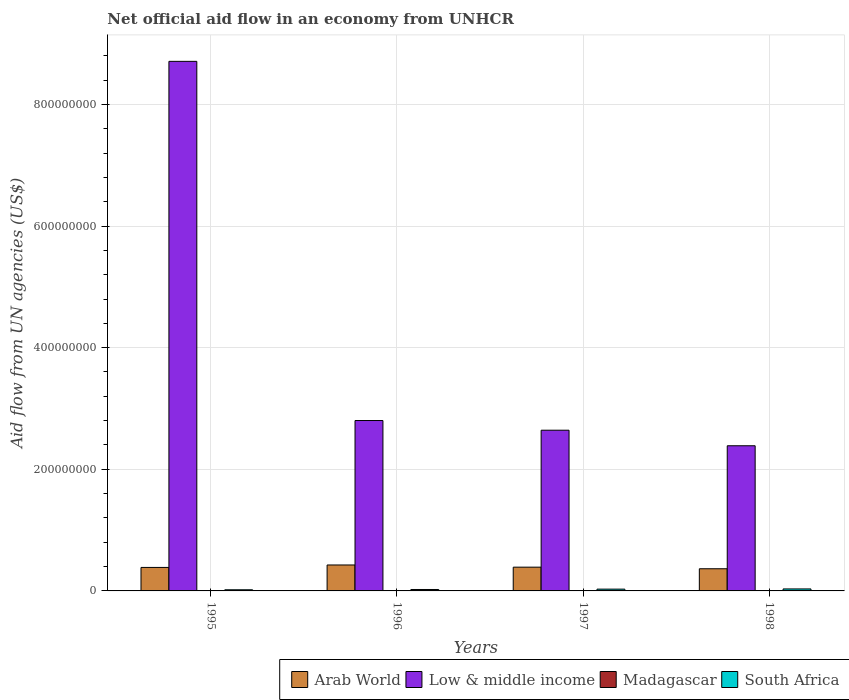Are the number of bars on each tick of the X-axis equal?
Your answer should be compact. Yes. How many bars are there on the 3rd tick from the right?
Make the answer very short. 4. In how many cases, is the number of bars for a given year not equal to the number of legend labels?
Your answer should be very brief. 0. What is the net official aid flow in Arab World in 1997?
Keep it short and to the point. 3.91e+07. Across all years, what is the maximum net official aid flow in Arab World?
Your answer should be compact. 4.27e+07. Across all years, what is the minimum net official aid flow in South Africa?
Make the answer very short. 1.88e+06. In which year was the net official aid flow in South Africa maximum?
Make the answer very short. 1998. In which year was the net official aid flow in South Africa minimum?
Give a very brief answer. 1995. What is the total net official aid flow in Arab World in the graph?
Give a very brief answer. 1.57e+08. What is the difference between the net official aid flow in Arab World in 1995 and that in 1996?
Make the answer very short. -4.03e+06. What is the difference between the net official aid flow in Low & middle income in 1997 and the net official aid flow in South Africa in 1996?
Make the answer very short. 2.62e+08. What is the average net official aid flow in Low & middle income per year?
Your answer should be compact. 4.14e+08. In the year 1996, what is the difference between the net official aid flow in Madagascar and net official aid flow in Arab World?
Your answer should be compact. -4.26e+07. What is the ratio of the net official aid flow in Arab World in 1996 to that in 1997?
Your response must be concise. 1.09. Is the difference between the net official aid flow in Madagascar in 1996 and 1997 greater than the difference between the net official aid flow in Arab World in 1996 and 1997?
Your answer should be compact. No. What is the difference between the highest and the second highest net official aid flow in Low & middle income?
Your answer should be compact. 5.91e+08. Is it the case that in every year, the sum of the net official aid flow in Low & middle income and net official aid flow in Arab World is greater than the sum of net official aid flow in Madagascar and net official aid flow in South Africa?
Make the answer very short. Yes. What does the 1st bar from the left in 1998 represents?
Keep it short and to the point. Arab World. What does the 2nd bar from the right in 1998 represents?
Provide a short and direct response. Madagascar. Is it the case that in every year, the sum of the net official aid flow in Madagascar and net official aid flow in South Africa is greater than the net official aid flow in Arab World?
Provide a short and direct response. No. How many bars are there?
Your response must be concise. 16. Are all the bars in the graph horizontal?
Your response must be concise. No. What is the difference between two consecutive major ticks on the Y-axis?
Your response must be concise. 2.00e+08. Are the values on the major ticks of Y-axis written in scientific E-notation?
Your response must be concise. No. Does the graph contain any zero values?
Ensure brevity in your answer.  No. Where does the legend appear in the graph?
Offer a terse response. Bottom right. How many legend labels are there?
Make the answer very short. 4. What is the title of the graph?
Give a very brief answer. Net official aid flow in an economy from UNHCR. What is the label or title of the X-axis?
Provide a succinct answer. Years. What is the label or title of the Y-axis?
Keep it short and to the point. Aid flow from UN agencies (US$). What is the Aid flow from UN agencies (US$) of Arab World in 1995?
Your answer should be compact. 3.86e+07. What is the Aid flow from UN agencies (US$) of Low & middle income in 1995?
Your answer should be very brief. 8.71e+08. What is the Aid flow from UN agencies (US$) in South Africa in 1995?
Ensure brevity in your answer.  1.88e+06. What is the Aid flow from UN agencies (US$) in Arab World in 1996?
Provide a succinct answer. 4.27e+07. What is the Aid flow from UN agencies (US$) of Low & middle income in 1996?
Ensure brevity in your answer.  2.80e+08. What is the Aid flow from UN agencies (US$) in Madagascar in 1996?
Your answer should be compact. 6.00e+04. What is the Aid flow from UN agencies (US$) in South Africa in 1996?
Ensure brevity in your answer.  2.35e+06. What is the Aid flow from UN agencies (US$) in Arab World in 1997?
Provide a succinct answer. 3.91e+07. What is the Aid flow from UN agencies (US$) in Low & middle income in 1997?
Give a very brief answer. 2.64e+08. What is the Aid flow from UN agencies (US$) of Madagascar in 1997?
Give a very brief answer. 5.00e+04. What is the Aid flow from UN agencies (US$) in South Africa in 1997?
Your response must be concise. 2.94e+06. What is the Aid flow from UN agencies (US$) in Arab World in 1998?
Keep it short and to the point. 3.64e+07. What is the Aid flow from UN agencies (US$) of Low & middle income in 1998?
Make the answer very short. 2.39e+08. What is the Aid flow from UN agencies (US$) of Madagascar in 1998?
Offer a very short reply. 4.00e+04. What is the Aid flow from UN agencies (US$) of South Africa in 1998?
Provide a short and direct response. 3.27e+06. Across all years, what is the maximum Aid flow from UN agencies (US$) of Arab World?
Your response must be concise. 4.27e+07. Across all years, what is the maximum Aid flow from UN agencies (US$) in Low & middle income?
Provide a succinct answer. 8.71e+08. Across all years, what is the maximum Aid flow from UN agencies (US$) of Madagascar?
Provide a succinct answer. 6.00e+04. Across all years, what is the maximum Aid flow from UN agencies (US$) of South Africa?
Provide a short and direct response. 3.27e+06. Across all years, what is the minimum Aid flow from UN agencies (US$) in Arab World?
Provide a succinct answer. 3.64e+07. Across all years, what is the minimum Aid flow from UN agencies (US$) of Low & middle income?
Your answer should be very brief. 2.39e+08. Across all years, what is the minimum Aid flow from UN agencies (US$) of Madagascar?
Your response must be concise. 4.00e+04. Across all years, what is the minimum Aid flow from UN agencies (US$) in South Africa?
Offer a very short reply. 1.88e+06. What is the total Aid flow from UN agencies (US$) in Arab World in the graph?
Your answer should be compact. 1.57e+08. What is the total Aid flow from UN agencies (US$) in Low & middle income in the graph?
Provide a short and direct response. 1.65e+09. What is the total Aid flow from UN agencies (US$) in Madagascar in the graph?
Offer a terse response. 1.90e+05. What is the total Aid flow from UN agencies (US$) in South Africa in the graph?
Make the answer very short. 1.04e+07. What is the difference between the Aid flow from UN agencies (US$) in Arab World in 1995 and that in 1996?
Your response must be concise. -4.03e+06. What is the difference between the Aid flow from UN agencies (US$) in Low & middle income in 1995 and that in 1996?
Ensure brevity in your answer.  5.91e+08. What is the difference between the Aid flow from UN agencies (US$) of Madagascar in 1995 and that in 1996?
Provide a succinct answer. -2.00e+04. What is the difference between the Aid flow from UN agencies (US$) of South Africa in 1995 and that in 1996?
Provide a short and direct response. -4.70e+05. What is the difference between the Aid flow from UN agencies (US$) in Arab World in 1995 and that in 1997?
Your answer should be compact. -4.30e+05. What is the difference between the Aid flow from UN agencies (US$) of Low & middle income in 1995 and that in 1997?
Your answer should be compact. 6.07e+08. What is the difference between the Aid flow from UN agencies (US$) in South Africa in 1995 and that in 1997?
Your answer should be compact. -1.06e+06. What is the difference between the Aid flow from UN agencies (US$) of Arab World in 1995 and that in 1998?
Offer a very short reply. 2.18e+06. What is the difference between the Aid flow from UN agencies (US$) in Low & middle income in 1995 and that in 1998?
Make the answer very short. 6.32e+08. What is the difference between the Aid flow from UN agencies (US$) of Madagascar in 1995 and that in 1998?
Your answer should be very brief. 0. What is the difference between the Aid flow from UN agencies (US$) in South Africa in 1995 and that in 1998?
Give a very brief answer. -1.39e+06. What is the difference between the Aid flow from UN agencies (US$) in Arab World in 1996 and that in 1997?
Ensure brevity in your answer.  3.60e+06. What is the difference between the Aid flow from UN agencies (US$) in Low & middle income in 1996 and that in 1997?
Ensure brevity in your answer.  1.59e+07. What is the difference between the Aid flow from UN agencies (US$) in South Africa in 1996 and that in 1997?
Make the answer very short. -5.90e+05. What is the difference between the Aid flow from UN agencies (US$) of Arab World in 1996 and that in 1998?
Provide a succinct answer. 6.21e+06. What is the difference between the Aid flow from UN agencies (US$) in Low & middle income in 1996 and that in 1998?
Offer a very short reply. 4.15e+07. What is the difference between the Aid flow from UN agencies (US$) in South Africa in 1996 and that in 1998?
Make the answer very short. -9.20e+05. What is the difference between the Aid flow from UN agencies (US$) in Arab World in 1997 and that in 1998?
Your answer should be compact. 2.61e+06. What is the difference between the Aid flow from UN agencies (US$) in Low & middle income in 1997 and that in 1998?
Your answer should be very brief. 2.56e+07. What is the difference between the Aid flow from UN agencies (US$) of Madagascar in 1997 and that in 1998?
Keep it short and to the point. 10000. What is the difference between the Aid flow from UN agencies (US$) of South Africa in 1997 and that in 1998?
Keep it short and to the point. -3.30e+05. What is the difference between the Aid flow from UN agencies (US$) in Arab World in 1995 and the Aid flow from UN agencies (US$) in Low & middle income in 1996?
Make the answer very short. -2.42e+08. What is the difference between the Aid flow from UN agencies (US$) of Arab World in 1995 and the Aid flow from UN agencies (US$) of Madagascar in 1996?
Keep it short and to the point. 3.86e+07. What is the difference between the Aid flow from UN agencies (US$) in Arab World in 1995 and the Aid flow from UN agencies (US$) in South Africa in 1996?
Provide a short and direct response. 3.63e+07. What is the difference between the Aid flow from UN agencies (US$) in Low & middle income in 1995 and the Aid flow from UN agencies (US$) in Madagascar in 1996?
Make the answer very short. 8.71e+08. What is the difference between the Aid flow from UN agencies (US$) of Low & middle income in 1995 and the Aid flow from UN agencies (US$) of South Africa in 1996?
Your answer should be compact. 8.68e+08. What is the difference between the Aid flow from UN agencies (US$) in Madagascar in 1995 and the Aid flow from UN agencies (US$) in South Africa in 1996?
Your response must be concise. -2.31e+06. What is the difference between the Aid flow from UN agencies (US$) in Arab World in 1995 and the Aid flow from UN agencies (US$) in Low & middle income in 1997?
Offer a terse response. -2.26e+08. What is the difference between the Aid flow from UN agencies (US$) in Arab World in 1995 and the Aid flow from UN agencies (US$) in Madagascar in 1997?
Give a very brief answer. 3.86e+07. What is the difference between the Aid flow from UN agencies (US$) in Arab World in 1995 and the Aid flow from UN agencies (US$) in South Africa in 1997?
Offer a terse response. 3.57e+07. What is the difference between the Aid flow from UN agencies (US$) of Low & middle income in 1995 and the Aid flow from UN agencies (US$) of Madagascar in 1997?
Give a very brief answer. 8.71e+08. What is the difference between the Aid flow from UN agencies (US$) in Low & middle income in 1995 and the Aid flow from UN agencies (US$) in South Africa in 1997?
Ensure brevity in your answer.  8.68e+08. What is the difference between the Aid flow from UN agencies (US$) in Madagascar in 1995 and the Aid flow from UN agencies (US$) in South Africa in 1997?
Offer a terse response. -2.90e+06. What is the difference between the Aid flow from UN agencies (US$) of Arab World in 1995 and the Aid flow from UN agencies (US$) of Low & middle income in 1998?
Your answer should be compact. -2.00e+08. What is the difference between the Aid flow from UN agencies (US$) of Arab World in 1995 and the Aid flow from UN agencies (US$) of Madagascar in 1998?
Provide a succinct answer. 3.86e+07. What is the difference between the Aid flow from UN agencies (US$) of Arab World in 1995 and the Aid flow from UN agencies (US$) of South Africa in 1998?
Offer a terse response. 3.54e+07. What is the difference between the Aid flow from UN agencies (US$) in Low & middle income in 1995 and the Aid flow from UN agencies (US$) in Madagascar in 1998?
Offer a very short reply. 8.71e+08. What is the difference between the Aid flow from UN agencies (US$) in Low & middle income in 1995 and the Aid flow from UN agencies (US$) in South Africa in 1998?
Offer a very short reply. 8.68e+08. What is the difference between the Aid flow from UN agencies (US$) in Madagascar in 1995 and the Aid flow from UN agencies (US$) in South Africa in 1998?
Provide a short and direct response. -3.23e+06. What is the difference between the Aid flow from UN agencies (US$) in Arab World in 1996 and the Aid flow from UN agencies (US$) in Low & middle income in 1997?
Offer a very short reply. -2.22e+08. What is the difference between the Aid flow from UN agencies (US$) of Arab World in 1996 and the Aid flow from UN agencies (US$) of Madagascar in 1997?
Keep it short and to the point. 4.26e+07. What is the difference between the Aid flow from UN agencies (US$) in Arab World in 1996 and the Aid flow from UN agencies (US$) in South Africa in 1997?
Give a very brief answer. 3.97e+07. What is the difference between the Aid flow from UN agencies (US$) in Low & middle income in 1996 and the Aid flow from UN agencies (US$) in Madagascar in 1997?
Make the answer very short. 2.80e+08. What is the difference between the Aid flow from UN agencies (US$) in Low & middle income in 1996 and the Aid flow from UN agencies (US$) in South Africa in 1997?
Keep it short and to the point. 2.77e+08. What is the difference between the Aid flow from UN agencies (US$) in Madagascar in 1996 and the Aid flow from UN agencies (US$) in South Africa in 1997?
Your answer should be very brief. -2.88e+06. What is the difference between the Aid flow from UN agencies (US$) of Arab World in 1996 and the Aid flow from UN agencies (US$) of Low & middle income in 1998?
Offer a very short reply. -1.96e+08. What is the difference between the Aid flow from UN agencies (US$) in Arab World in 1996 and the Aid flow from UN agencies (US$) in Madagascar in 1998?
Give a very brief answer. 4.26e+07. What is the difference between the Aid flow from UN agencies (US$) in Arab World in 1996 and the Aid flow from UN agencies (US$) in South Africa in 1998?
Provide a succinct answer. 3.94e+07. What is the difference between the Aid flow from UN agencies (US$) in Low & middle income in 1996 and the Aid flow from UN agencies (US$) in Madagascar in 1998?
Keep it short and to the point. 2.80e+08. What is the difference between the Aid flow from UN agencies (US$) of Low & middle income in 1996 and the Aid flow from UN agencies (US$) of South Africa in 1998?
Make the answer very short. 2.77e+08. What is the difference between the Aid flow from UN agencies (US$) in Madagascar in 1996 and the Aid flow from UN agencies (US$) in South Africa in 1998?
Keep it short and to the point. -3.21e+06. What is the difference between the Aid flow from UN agencies (US$) of Arab World in 1997 and the Aid flow from UN agencies (US$) of Low & middle income in 1998?
Keep it short and to the point. -2.00e+08. What is the difference between the Aid flow from UN agencies (US$) of Arab World in 1997 and the Aid flow from UN agencies (US$) of Madagascar in 1998?
Your response must be concise. 3.90e+07. What is the difference between the Aid flow from UN agencies (US$) of Arab World in 1997 and the Aid flow from UN agencies (US$) of South Africa in 1998?
Your answer should be very brief. 3.58e+07. What is the difference between the Aid flow from UN agencies (US$) in Low & middle income in 1997 and the Aid flow from UN agencies (US$) in Madagascar in 1998?
Ensure brevity in your answer.  2.64e+08. What is the difference between the Aid flow from UN agencies (US$) in Low & middle income in 1997 and the Aid flow from UN agencies (US$) in South Africa in 1998?
Offer a very short reply. 2.61e+08. What is the difference between the Aid flow from UN agencies (US$) of Madagascar in 1997 and the Aid flow from UN agencies (US$) of South Africa in 1998?
Offer a terse response. -3.22e+06. What is the average Aid flow from UN agencies (US$) of Arab World per year?
Keep it short and to the point. 3.92e+07. What is the average Aid flow from UN agencies (US$) in Low & middle income per year?
Give a very brief answer. 4.14e+08. What is the average Aid flow from UN agencies (US$) of Madagascar per year?
Give a very brief answer. 4.75e+04. What is the average Aid flow from UN agencies (US$) in South Africa per year?
Keep it short and to the point. 2.61e+06. In the year 1995, what is the difference between the Aid flow from UN agencies (US$) in Arab World and Aid flow from UN agencies (US$) in Low & middle income?
Your response must be concise. -8.32e+08. In the year 1995, what is the difference between the Aid flow from UN agencies (US$) of Arab World and Aid flow from UN agencies (US$) of Madagascar?
Make the answer very short. 3.86e+07. In the year 1995, what is the difference between the Aid flow from UN agencies (US$) of Arab World and Aid flow from UN agencies (US$) of South Africa?
Offer a terse response. 3.68e+07. In the year 1995, what is the difference between the Aid flow from UN agencies (US$) of Low & middle income and Aid flow from UN agencies (US$) of Madagascar?
Ensure brevity in your answer.  8.71e+08. In the year 1995, what is the difference between the Aid flow from UN agencies (US$) in Low & middle income and Aid flow from UN agencies (US$) in South Africa?
Your answer should be very brief. 8.69e+08. In the year 1995, what is the difference between the Aid flow from UN agencies (US$) of Madagascar and Aid flow from UN agencies (US$) of South Africa?
Provide a short and direct response. -1.84e+06. In the year 1996, what is the difference between the Aid flow from UN agencies (US$) in Arab World and Aid flow from UN agencies (US$) in Low & middle income?
Keep it short and to the point. -2.38e+08. In the year 1996, what is the difference between the Aid flow from UN agencies (US$) in Arab World and Aid flow from UN agencies (US$) in Madagascar?
Your answer should be very brief. 4.26e+07. In the year 1996, what is the difference between the Aid flow from UN agencies (US$) of Arab World and Aid flow from UN agencies (US$) of South Africa?
Offer a terse response. 4.03e+07. In the year 1996, what is the difference between the Aid flow from UN agencies (US$) in Low & middle income and Aid flow from UN agencies (US$) in Madagascar?
Ensure brevity in your answer.  2.80e+08. In the year 1996, what is the difference between the Aid flow from UN agencies (US$) in Low & middle income and Aid flow from UN agencies (US$) in South Africa?
Keep it short and to the point. 2.78e+08. In the year 1996, what is the difference between the Aid flow from UN agencies (US$) of Madagascar and Aid flow from UN agencies (US$) of South Africa?
Ensure brevity in your answer.  -2.29e+06. In the year 1997, what is the difference between the Aid flow from UN agencies (US$) in Arab World and Aid flow from UN agencies (US$) in Low & middle income?
Offer a very short reply. -2.25e+08. In the year 1997, what is the difference between the Aid flow from UN agencies (US$) in Arab World and Aid flow from UN agencies (US$) in Madagascar?
Give a very brief answer. 3.90e+07. In the year 1997, what is the difference between the Aid flow from UN agencies (US$) in Arab World and Aid flow from UN agencies (US$) in South Africa?
Give a very brief answer. 3.61e+07. In the year 1997, what is the difference between the Aid flow from UN agencies (US$) of Low & middle income and Aid flow from UN agencies (US$) of Madagascar?
Keep it short and to the point. 2.64e+08. In the year 1997, what is the difference between the Aid flow from UN agencies (US$) in Low & middle income and Aid flow from UN agencies (US$) in South Africa?
Provide a succinct answer. 2.61e+08. In the year 1997, what is the difference between the Aid flow from UN agencies (US$) of Madagascar and Aid flow from UN agencies (US$) of South Africa?
Give a very brief answer. -2.89e+06. In the year 1998, what is the difference between the Aid flow from UN agencies (US$) of Arab World and Aid flow from UN agencies (US$) of Low & middle income?
Offer a very short reply. -2.02e+08. In the year 1998, what is the difference between the Aid flow from UN agencies (US$) in Arab World and Aid flow from UN agencies (US$) in Madagascar?
Ensure brevity in your answer.  3.64e+07. In the year 1998, what is the difference between the Aid flow from UN agencies (US$) in Arab World and Aid flow from UN agencies (US$) in South Africa?
Keep it short and to the point. 3.32e+07. In the year 1998, what is the difference between the Aid flow from UN agencies (US$) of Low & middle income and Aid flow from UN agencies (US$) of Madagascar?
Make the answer very short. 2.39e+08. In the year 1998, what is the difference between the Aid flow from UN agencies (US$) of Low & middle income and Aid flow from UN agencies (US$) of South Africa?
Make the answer very short. 2.35e+08. In the year 1998, what is the difference between the Aid flow from UN agencies (US$) of Madagascar and Aid flow from UN agencies (US$) of South Africa?
Ensure brevity in your answer.  -3.23e+06. What is the ratio of the Aid flow from UN agencies (US$) of Arab World in 1995 to that in 1996?
Provide a short and direct response. 0.91. What is the ratio of the Aid flow from UN agencies (US$) in Low & middle income in 1995 to that in 1996?
Make the answer very short. 3.11. What is the ratio of the Aid flow from UN agencies (US$) of Arab World in 1995 to that in 1997?
Keep it short and to the point. 0.99. What is the ratio of the Aid flow from UN agencies (US$) in Low & middle income in 1995 to that in 1997?
Your answer should be compact. 3.3. What is the ratio of the Aid flow from UN agencies (US$) of Madagascar in 1995 to that in 1997?
Provide a succinct answer. 0.8. What is the ratio of the Aid flow from UN agencies (US$) of South Africa in 1995 to that in 1997?
Ensure brevity in your answer.  0.64. What is the ratio of the Aid flow from UN agencies (US$) of Arab World in 1995 to that in 1998?
Offer a terse response. 1.06. What is the ratio of the Aid flow from UN agencies (US$) of Low & middle income in 1995 to that in 1998?
Give a very brief answer. 3.65. What is the ratio of the Aid flow from UN agencies (US$) of Madagascar in 1995 to that in 1998?
Your answer should be very brief. 1. What is the ratio of the Aid flow from UN agencies (US$) in South Africa in 1995 to that in 1998?
Offer a very short reply. 0.57. What is the ratio of the Aid flow from UN agencies (US$) in Arab World in 1996 to that in 1997?
Your answer should be compact. 1.09. What is the ratio of the Aid flow from UN agencies (US$) in Low & middle income in 1996 to that in 1997?
Your answer should be compact. 1.06. What is the ratio of the Aid flow from UN agencies (US$) in Madagascar in 1996 to that in 1997?
Keep it short and to the point. 1.2. What is the ratio of the Aid flow from UN agencies (US$) in South Africa in 1996 to that in 1997?
Provide a short and direct response. 0.8. What is the ratio of the Aid flow from UN agencies (US$) in Arab World in 1996 to that in 1998?
Give a very brief answer. 1.17. What is the ratio of the Aid flow from UN agencies (US$) in Low & middle income in 1996 to that in 1998?
Offer a terse response. 1.17. What is the ratio of the Aid flow from UN agencies (US$) in Madagascar in 1996 to that in 1998?
Keep it short and to the point. 1.5. What is the ratio of the Aid flow from UN agencies (US$) of South Africa in 1996 to that in 1998?
Your response must be concise. 0.72. What is the ratio of the Aid flow from UN agencies (US$) in Arab World in 1997 to that in 1998?
Your response must be concise. 1.07. What is the ratio of the Aid flow from UN agencies (US$) in Low & middle income in 1997 to that in 1998?
Provide a succinct answer. 1.11. What is the ratio of the Aid flow from UN agencies (US$) of Madagascar in 1997 to that in 1998?
Offer a very short reply. 1.25. What is the ratio of the Aid flow from UN agencies (US$) in South Africa in 1997 to that in 1998?
Make the answer very short. 0.9. What is the difference between the highest and the second highest Aid flow from UN agencies (US$) of Arab World?
Your answer should be compact. 3.60e+06. What is the difference between the highest and the second highest Aid flow from UN agencies (US$) in Low & middle income?
Your response must be concise. 5.91e+08. What is the difference between the highest and the second highest Aid flow from UN agencies (US$) in Madagascar?
Keep it short and to the point. 10000. What is the difference between the highest and the lowest Aid flow from UN agencies (US$) in Arab World?
Give a very brief answer. 6.21e+06. What is the difference between the highest and the lowest Aid flow from UN agencies (US$) in Low & middle income?
Make the answer very short. 6.32e+08. What is the difference between the highest and the lowest Aid flow from UN agencies (US$) of Madagascar?
Give a very brief answer. 2.00e+04. What is the difference between the highest and the lowest Aid flow from UN agencies (US$) of South Africa?
Make the answer very short. 1.39e+06. 